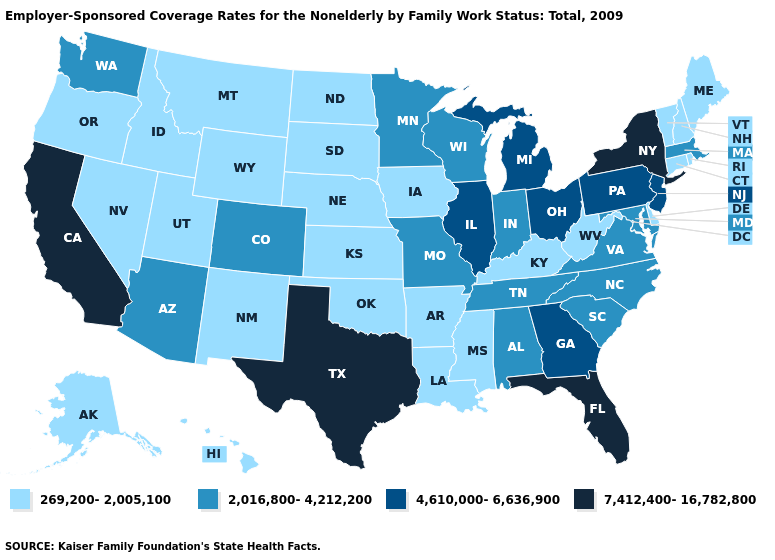What is the value of Mississippi?
Write a very short answer. 269,200-2,005,100. Name the states that have a value in the range 269,200-2,005,100?
Quick response, please. Alaska, Arkansas, Connecticut, Delaware, Hawaii, Idaho, Iowa, Kansas, Kentucky, Louisiana, Maine, Mississippi, Montana, Nebraska, Nevada, New Hampshire, New Mexico, North Dakota, Oklahoma, Oregon, Rhode Island, South Dakota, Utah, Vermont, West Virginia, Wyoming. How many symbols are there in the legend?
Give a very brief answer. 4. Which states have the highest value in the USA?
Keep it brief. California, Florida, New York, Texas. Does Kentucky have the lowest value in the USA?
Write a very short answer. Yes. Name the states that have a value in the range 7,412,400-16,782,800?
Give a very brief answer. California, Florida, New York, Texas. Name the states that have a value in the range 4,610,000-6,636,900?
Be succinct. Georgia, Illinois, Michigan, New Jersey, Ohio, Pennsylvania. Does New York have the highest value in the USA?
Give a very brief answer. Yes. Among the states that border Virginia , does North Carolina have the lowest value?
Keep it brief. No. Name the states that have a value in the range 269,200-2,005,100?
Short answer required. Alaska, Arkansas, Connecticut, Delaware, Hawaii, Idaho, Iowa, Kansas, Kentucky, Louisiana, Maine, Mississippi, Montana, Nebraska, Nevada, New Hampshire, New Mexico, North Dakota, Oklahoma, Oregon, Rhode Island, South Dakota, Utah, Vermont, West Virginia, Wyoming. Does the first symbol in the legend represent the smallest category?
Short answer required. Yes. Does South Dakota have the lowest value in the MidWest?
Answer briefly. Yes. Does the map have missing data?
Write a very short answer. No. What is the highest value in the USA?
Be succinct. 7,412,400-16,782,800. What is the lowest value in the MidWest?
Answer briefly. 269,200-2,005,100. 